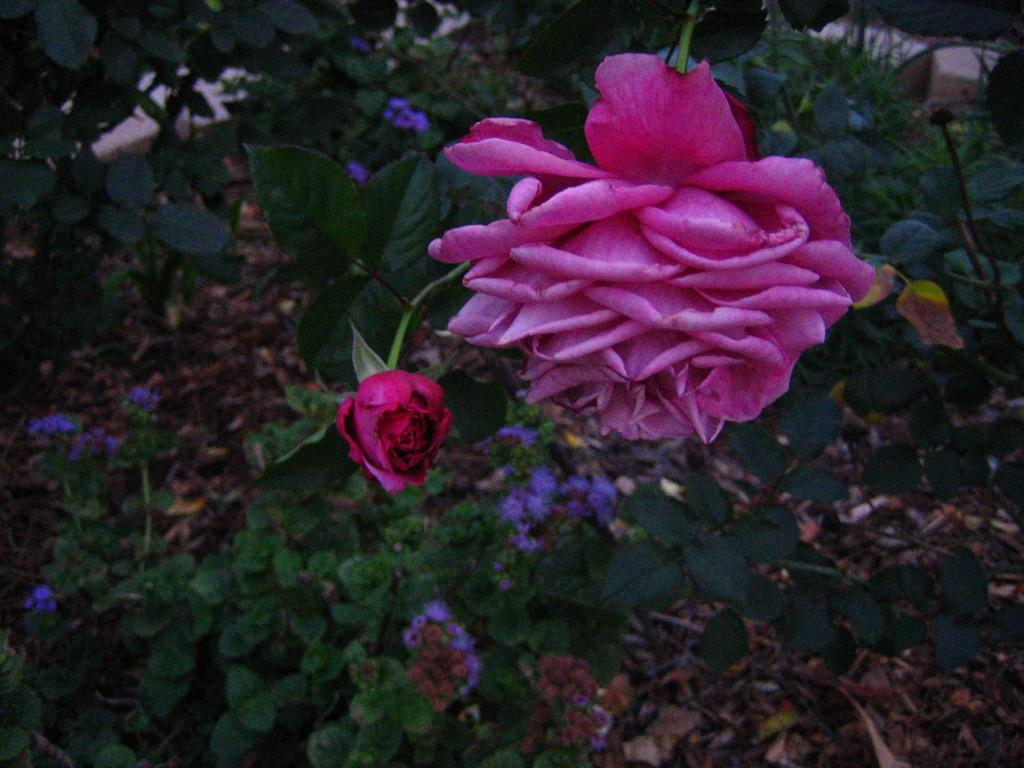What type of plants can be seen in the image? There are flower plants in the image. What discovery was made by the aunt in the image? There is no mention of an aunt or any discovery in the image, as it only features flower plants. 